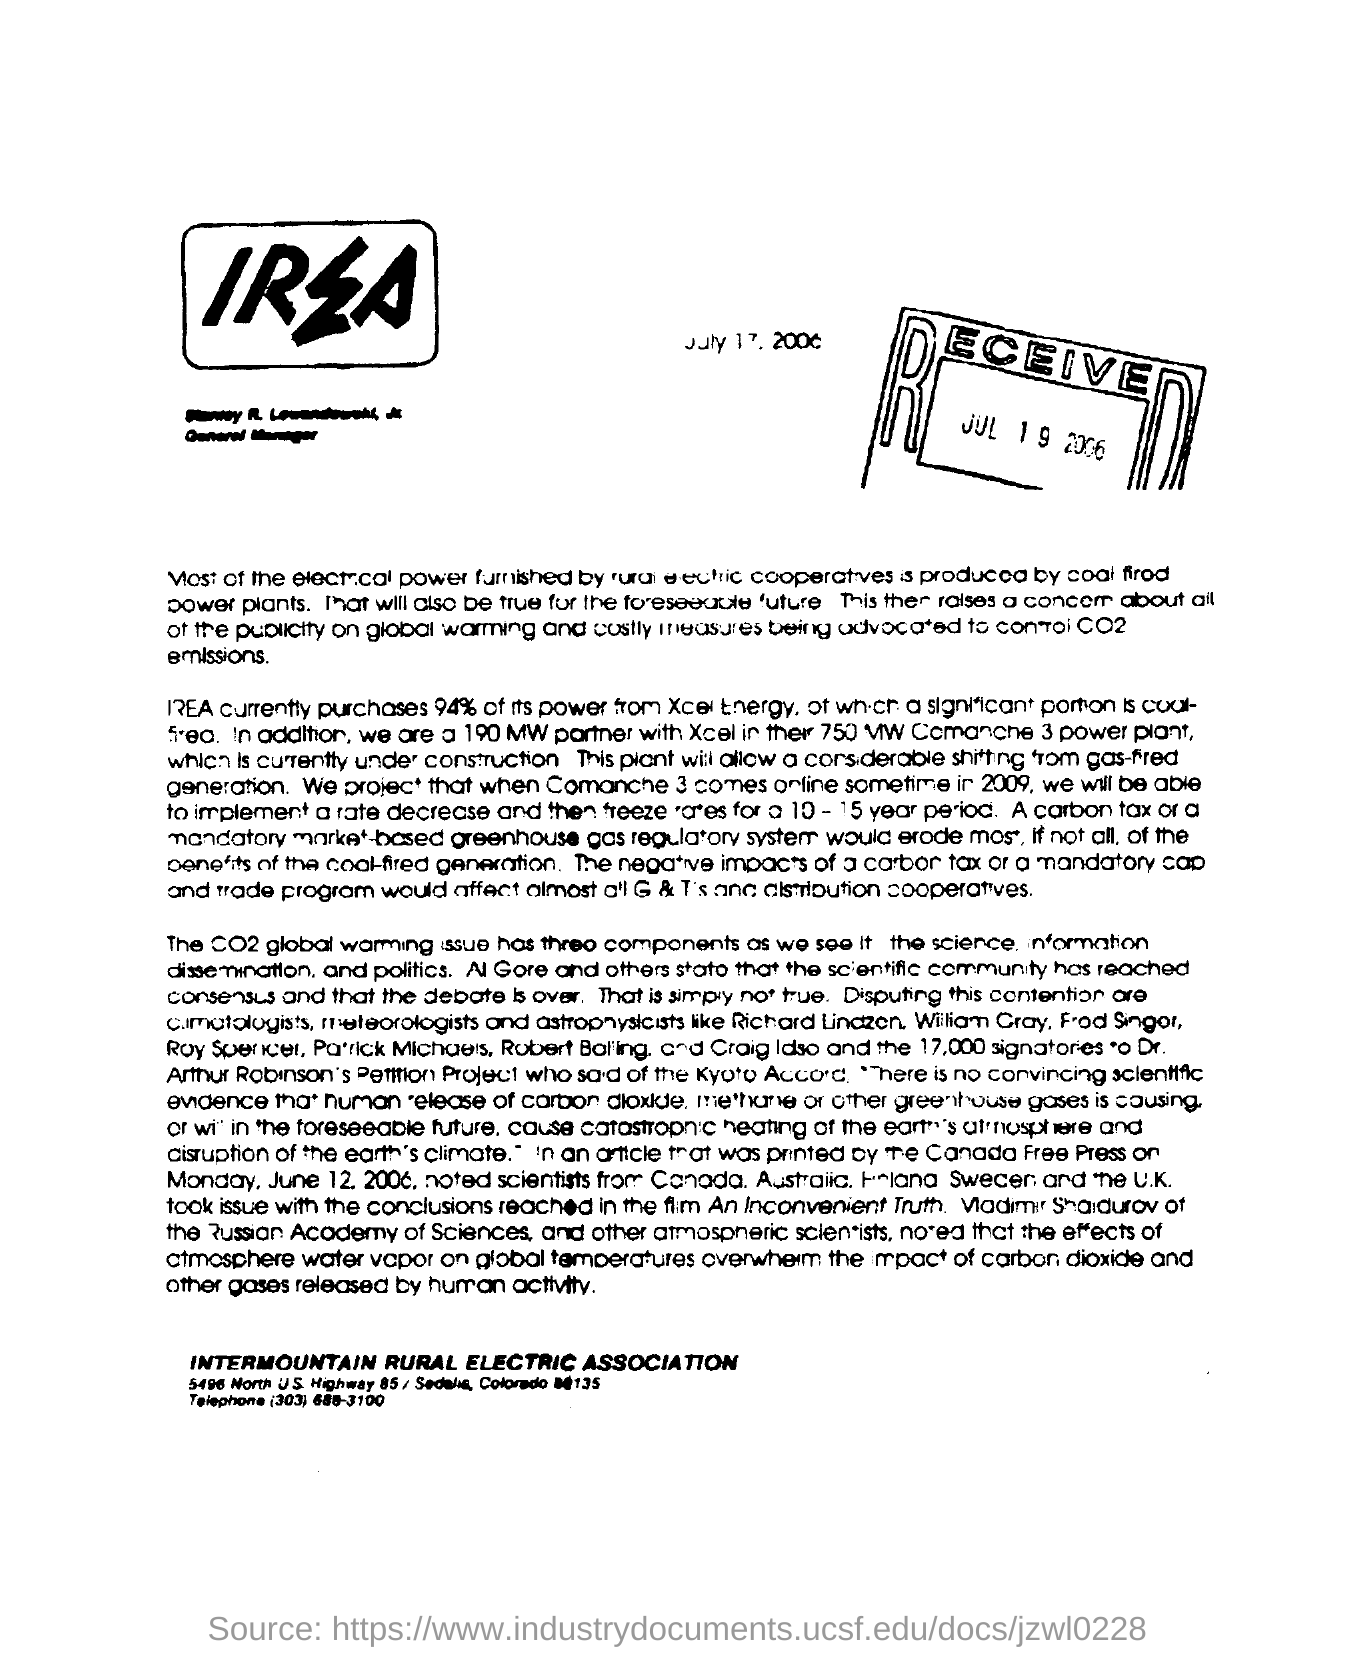What is the Received date mentioned in the document?
Keep it short and to the point. JUL 19 2006. 